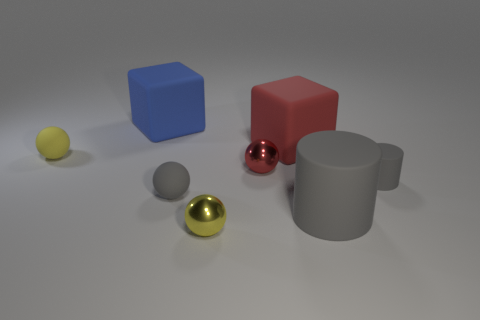How many other things are the same material as the red block?
Offer a terse response. 5. Is the number of large gray rubber things that are to the left of the gray ball the same as the number of small balls that are on the right side of the small red thing?
Offer a terse response. Yes. There is a thing that is on the right side of the large rubber thing in front of the matte cube that is in front of the large blue object; what color is it?
Offer a terse response. Gray. There is a small rubber thing to the left of the blue matte cube; what is its shape?
Provide a succinct answer. Sphere. There is a big blue thing that is the same material as the large cylinder; what shape is it?
Make the answer very short. Cube. There is a small gray matte cylinder; what number of small red metal balls are in front of it?
Provide a short and direct response. 0. Is the number of yellow things behind the large rubber cylinder the same as the number of small yellow metal things?
Ensure brevity in your answer.  Yes. Is the material of the blue cube the same as the big red cube?
Give a very brief answer. Yes. There is a rubber object that is both behind the tiny yellow matte thing and on the left side of the small gray matte ball; what is its size?
Offer a terse response. Large. What number of rubber things have the same size as the gray sphere?
Ensure brevity in your answer.  2. 